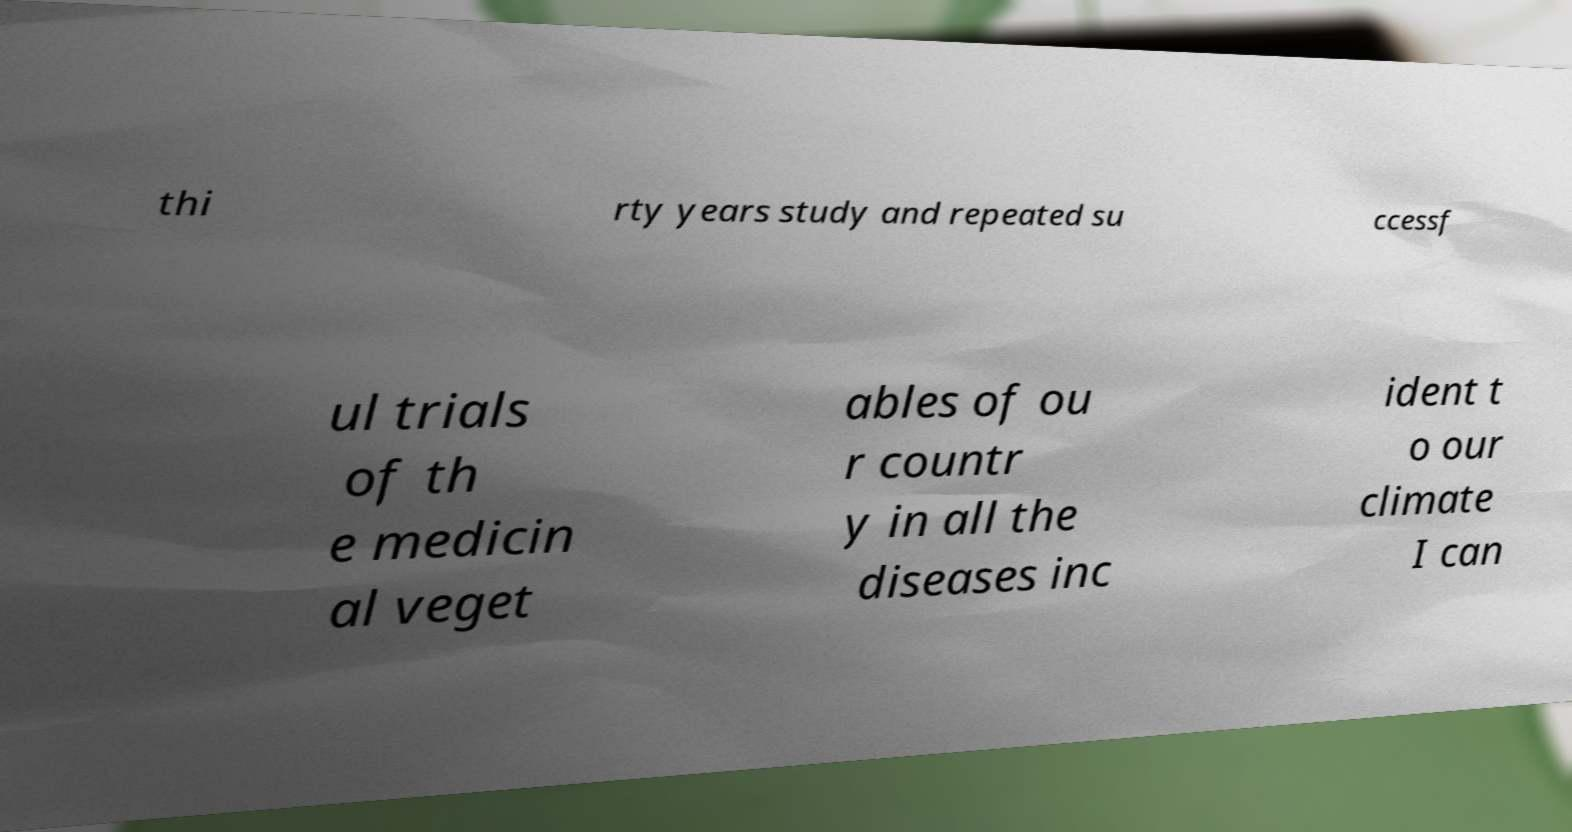Could you assist in decoding the text presented in this image and type it out clearly? thi rty years study and repeated su ccessf ul trials of th e medicin al veget ables of ou r countr y in all the diseases inc ident t o our climate I can 